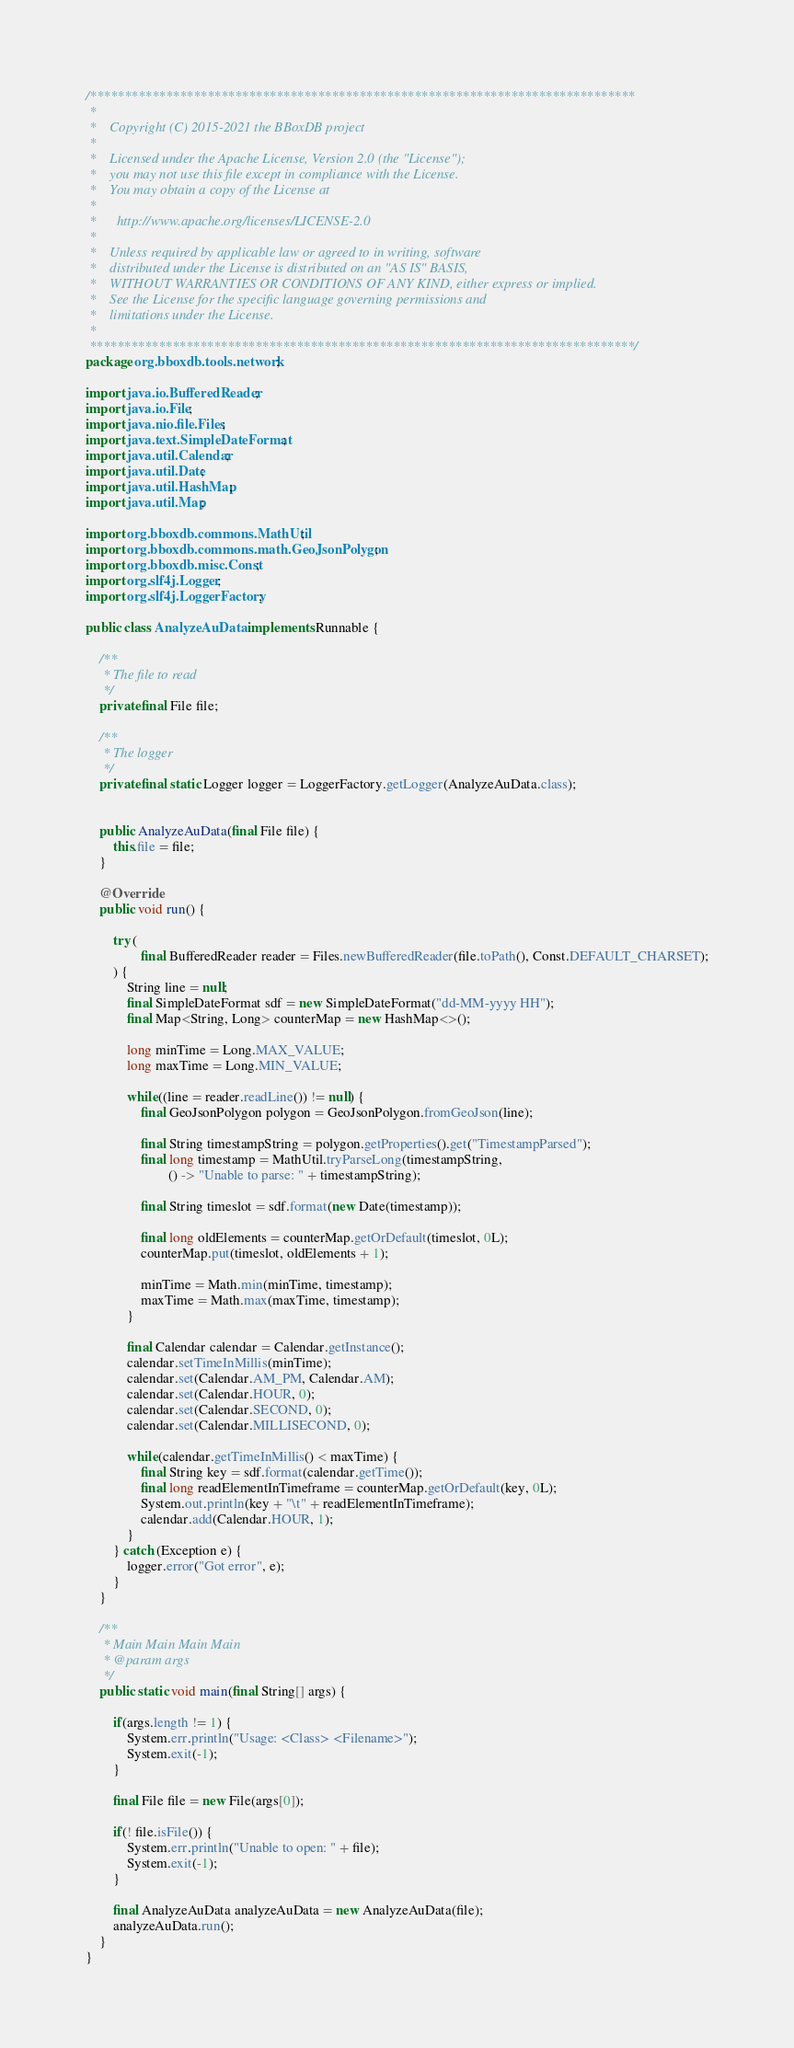Convert code to text. <code><loc_0><loc_0><loc_500><loc_500><_Java_>/*******************************************************************************
 *
 *    Copyright (C) 2015-2021 the BBoxDB project
 *  
 *    Licensed under the Apache License, Version 2.0 (the "License");
 *    you may not use this file except in compliance with the License.
 *    You may obtain a copy of the License at
 *  
 *      http://www.apache.org/licenses/LICENSE-2.0
 *  
 *    Unless required by applicable law or agreed to in writing, software
 *    distributed under the License is distributed on an "AS IS" BASIS,
 *    WITHOUT WARRANTIES OR CONDITIONS OF ANY KIND, either express or implied.
 *    See the License for the specific language governing permissions and
 *    limitations under the License. 
 *    
 *******************************************************************************/
package org.bboxdb.tools.network;

import java.io.BufferedReader;
import java.io.File;
import java.nio.file.Files;
import java.text.SimpleDateFormat;
import java.util.Calendar;
import java.util.Date;
import java.util.HashMap;
import java.util.Map;

import org.bboxdb.commons.MathUtil;
import org.bboxdb.commons.math.GeoJsonPolygon;
import org.bboxdb.misc.Const;
import org.slf4j.Logger;
import org.slf4j.LoggerFactory;

public class AnalyzeAuData implements Runnable {
	
	/**
	 * The file to read
	 */
	private final File file;
	
	/**
	 * The logger
	 */
	private final static Logger logger = LoggerFactory.getLogger(AnalyzeAuData.class);
	
	
	public AnalyzeAuData(final File file) {
		this.file = file;
	}

	@Override
	public void run() {
		
		try (
				final BufferedReader reader = Files.newBufferedReader(file.toPath(), Const.DEFAULT_CHARSET);
		) {
			String line = null;
			final SimpleDateFormat sdf = new SimpleDateFormat("dd-MM-yyyy HH");
			final Map<String, Long> counterMap = new HashMap<>();
			
			long minTime = Long.MAX_VALUE;
			long maxTime = Long.MIN_VALUE;
			
			while((line = reader.readLine()) != null) {
				final GeoJsonPolygon polygon = GeoJsonPolygon.fromGeoJson(line);
				
				final String timestampString = polygon.getProperties().get("TimestampParsed");
				final long timestamp = MathUtil.tryParseLong(timestampString, 
						() -> "Unable to parse: " + timestampString);
				
				final String timeslot = sdf.format(new Date(timestamp));
				
				final long oldElements = counterMap.getOrDefault(timeslot, 0L);
				counterMap.put(timeslot, oldElements + 1);
				
				minTime = Math.min(minTime, timestamp);
				maxTime = Math.max(maxTime, timestamp);
			}
			
		    final Calendar calendar = Calendar.getInstance();
		    calendar.setTimeInMillis(minTime);
		    calendar.set(Calendar.AM_PM, Calendar.AM);
			calendar.set(Calendar.HOUR, 0);
			calendar.set(Calendar.SECOND, 0);
			calendar.set(Calendar.MILLISECOND, 0);
			
			while(calendar.getTimeInMillis() < maxTime) {
				final String key = sdf.format(calendar.getTime());
				final long readElementInTimeframe = counterMap.getOrDefault(key, 0L);
				System.out.println(key + "\t" + readElementInTimeframe);
				calendar.add(Calendar.HOUR, 1);
			}	
		} catch (Exception e) {
			logger.error("Got error", e);
		} 
	}

	/**
	 * Main Main Main Main
	 * @param args
	 */
	public static void main(final String[] args) {
		
		if(args.length != 1) {
			System.err.println("Usage: <Class> <Filename>");
			System.exit(-1);
		}
		
		final File file = new File(args[0]);
		
		if(! file.isFile()) {
			System.err.println("Unable to open: " + file);
			System.exit(-1);
		}
		
		final AnalyzeAuData analyzeAuData = new AnalyzeAuData(file);
		analyzeAuData.run();
	}
}</code> 